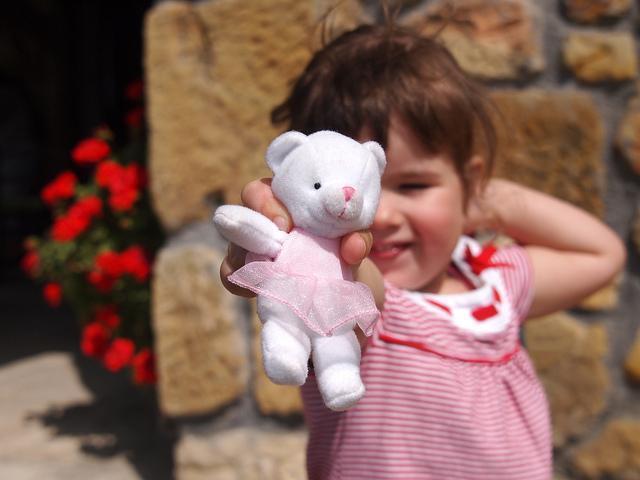What is she doing with the stuffed animal?
From the following set of four choices, select the accurate answer to respond to the question.
Options: Showing it, breaking it, selling it, squeezing it. Squeezing it. 